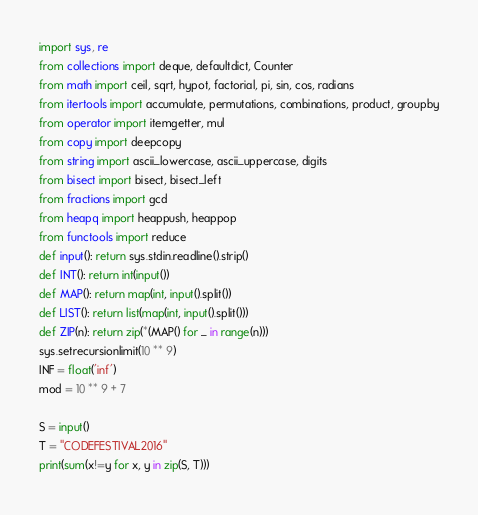<code> <loc_0><loc_0><loc_500><loc_500><_Python_>import sys, re
from collections import deque, defaultdict, Counter
from math import ceil, sqrt, hypot, factorial, pi, sin, cos, radians
from itertools import accumulate, permutations, combinations, product, groupby
from operator import itemgetter, mul
from copy import deepcopy
from string import ascii_lowercase, ascii_uppercase, digits
from bisect import bisect, bisect_left
from fractions import gcd
from heapq import heappush, heappop
from functools import reduce
def input(): return sys.stdin.readline().strip()
def INT(): return int(input())
def MAP(): return map(int, input().split())
def LIST(): return list(map(int, input().split()))
def ZIP(n): return zip(*(MAP() for _ in range(n)))
sys.setrecursionlimit(10 ** 9)
INF = float('inf')
mod = 10 ** 9 + 7

S = input()
T = "CODEFESTIVAL2016"
print(sum(x!=y for x, y in zip(S, T)))
</code> 